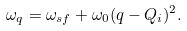<formula> <loc_0><loc_0><loc_500><loc_500>\omega _ { q } = \omega _ { s f } + \omega _ { 0 } ( { q } - { Q } _ { i } ) ^ { 2 } .</formula> 